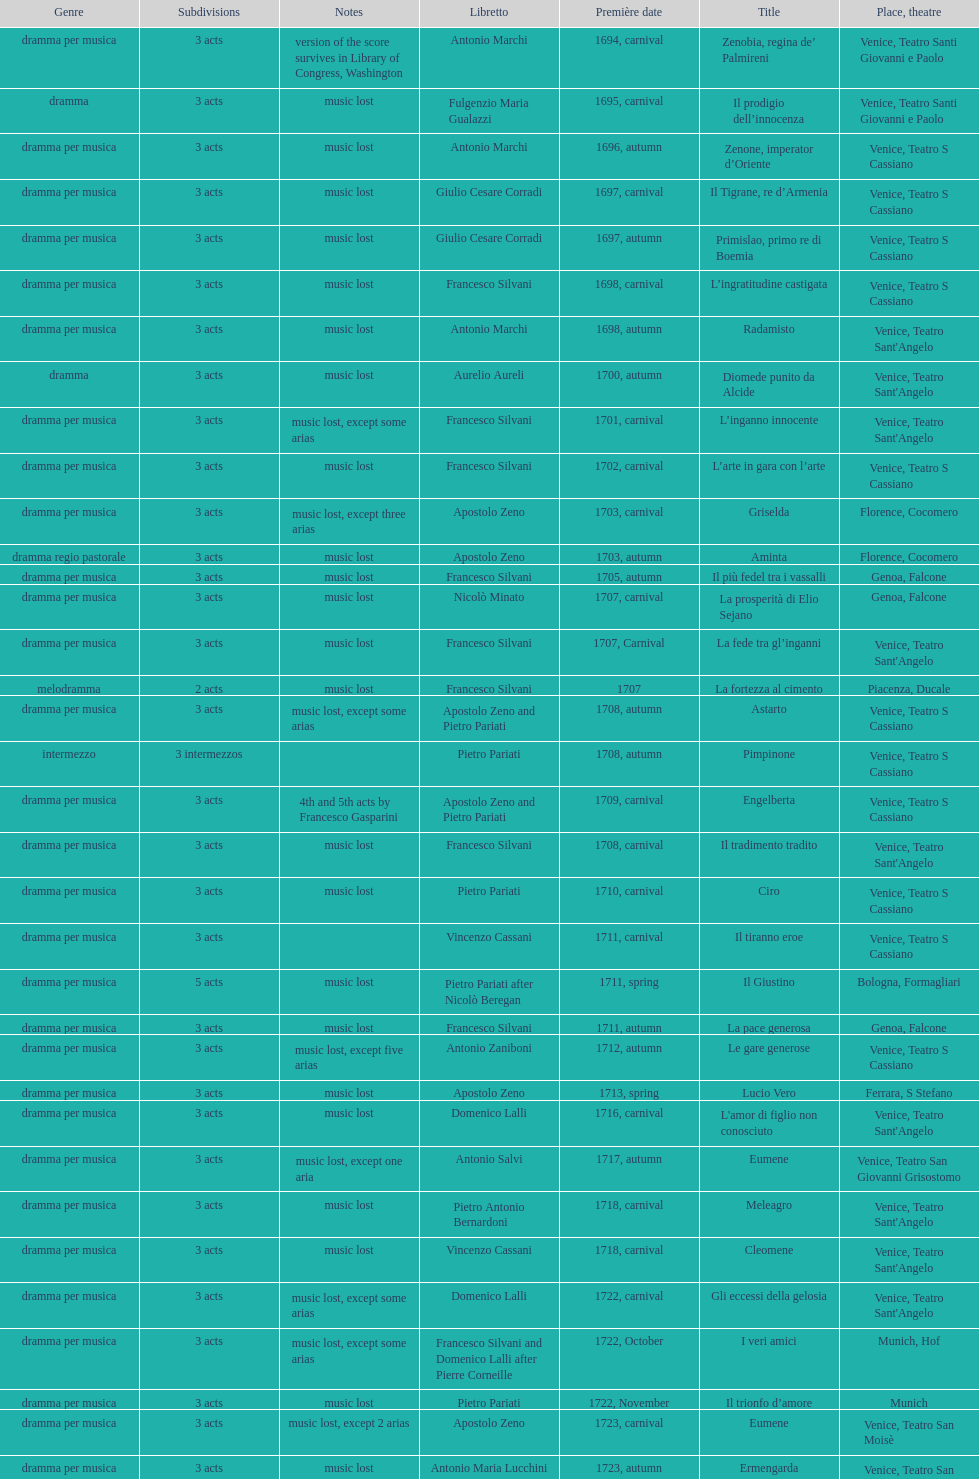What number of acts does il giustino have? 5. 